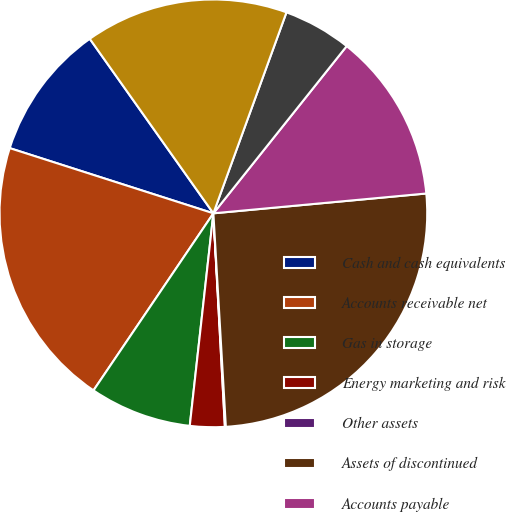Convert chart. <chart><loc_0><loc_0><loc_500><loc_500><pie_chart><fcel>Cash and cash equivalents<fcel>Accounts receivable net<fcel>Gas in storage<fcel>Energy marketing and risk<fcel>Other assets<fcel>Assets of discontinued<fcel>Accounts payable<fcel>Other liabilities<fcel>Liabilities of discontinued<nl><fcel>10.26%<fcel>20.46%<fcel>7.71%<fcel>2.62%<fcel>0.07%<fcel>25.55%<fcel>12.81%<fcel>5.16%<fcel>15.36%<nl></chart> 